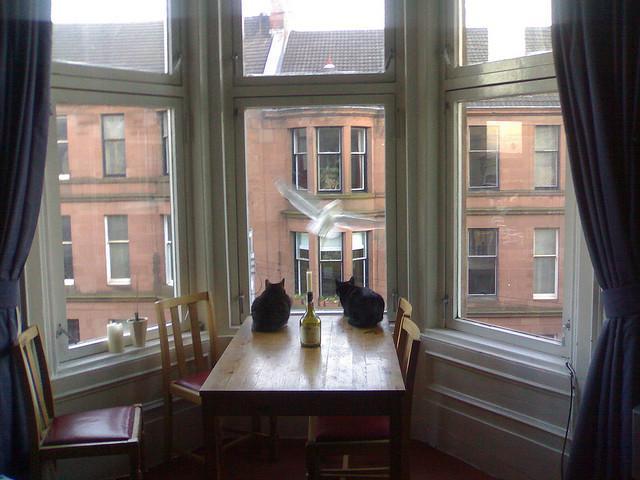How many animals are in this picture?
Give a very brief answer. 2. How many chairs are in the picture?
Give a very brief answer. 3. 